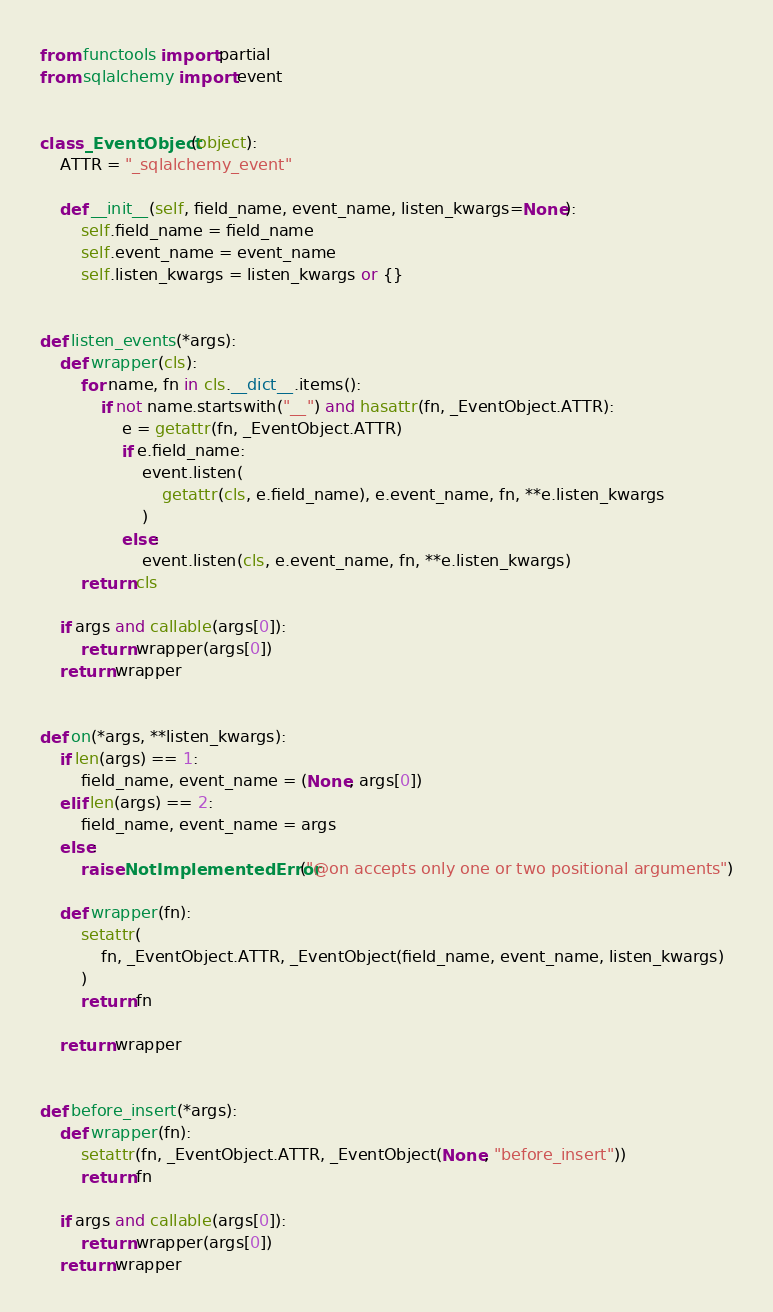<code> <loc_0><loc_0><loc_500><loc_500><_Python_>from functools import partial
from sqlalchemy import event


class _EventObject(object):
    ATTR = "_sqlalchemy_event"

    def __init__(self, field_name, event_name, listen_kwargs=None):
        self.field_name = field_name
        self.event_name = event_name
        self.listen_kwargs = listen_kwargs or {}


def listen_events(*args):
    def wrapper(cls):
        for name, fn in cls.__dict__.items():
            if not name.startswith("__") and hasattr(fn, _EventObject.ATTR):
                e = getattr(fn, _EventObject.ATTR)
                if e.field_name:
                    event.listen(
                        getattr(cls, e.field_name), e.event_name, fn, **e.listen_kwargs
                    )
                else:
                    event.listen(cls, e.event_name, fn, **e.listen_kwargs)
        return cls

    if args and callable(args[0]):
        return wrapper(args[0])
    return wrapper


def on(*args, **listen_kwargs):
    if len(args) == 1:
        field_name, event_name = (None, args[0])
    elif len(args) == 2:
        field_name, event_name = args
    else:
        raise NotImplementedError("@on accepts only one or two positional arguments")

    def wrapper(fn):
        setattr(
            fn, _EventObject.ATTR, _EventObject(field_name, event_name, listen_kwargs)
        )
        return fn

    return wrapper


def before_insert(*args):
    def wrapper(fn):
        setattr(fn, _EventObject.ATTR, _EventObject(None, "before_insert"))
        return fn

    if args and callable(args[0]):
        return wrapper(args[0])
    return wrapper
</code> 